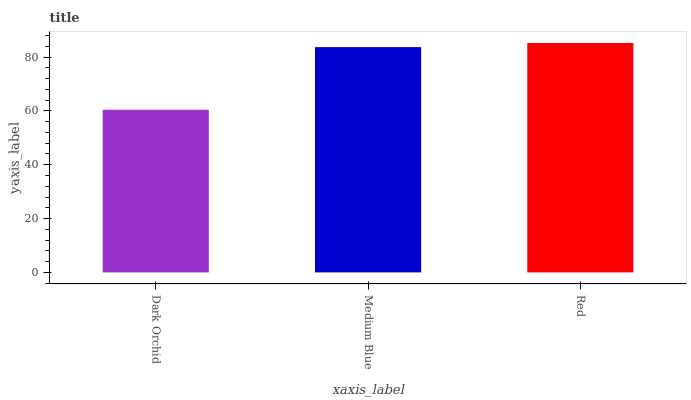Is Dark Orchid the minimum?
Answer yes or no. Yes. Is Red the maximum?
Answer yes or no. Yes. Is Medium Blue the minimum?
Answer yes or no. No. Is Medium Blue the maximum?
Answer yes or no. No. Is Medium Blue greater than Dark Orchid?
Answer yes or no. Yes. Is Dark Orchid less than Medium Blue?
Answer yes or no. Yes. Is Dark Orchid greater than Medium Blue?
Answer yes or no. No. Is Medium Blue less than Dark Orchid?
Answer yes or no. No. Is Medium Blue the high median?
Answer yes or no. Yes. Is Medium Blue the low median?
Answer yes or no. Yes. Is Dark Orchid the high median?
Answer yes or no. No. Is Dark Orchid the low median?
Answer yes or no. No. 